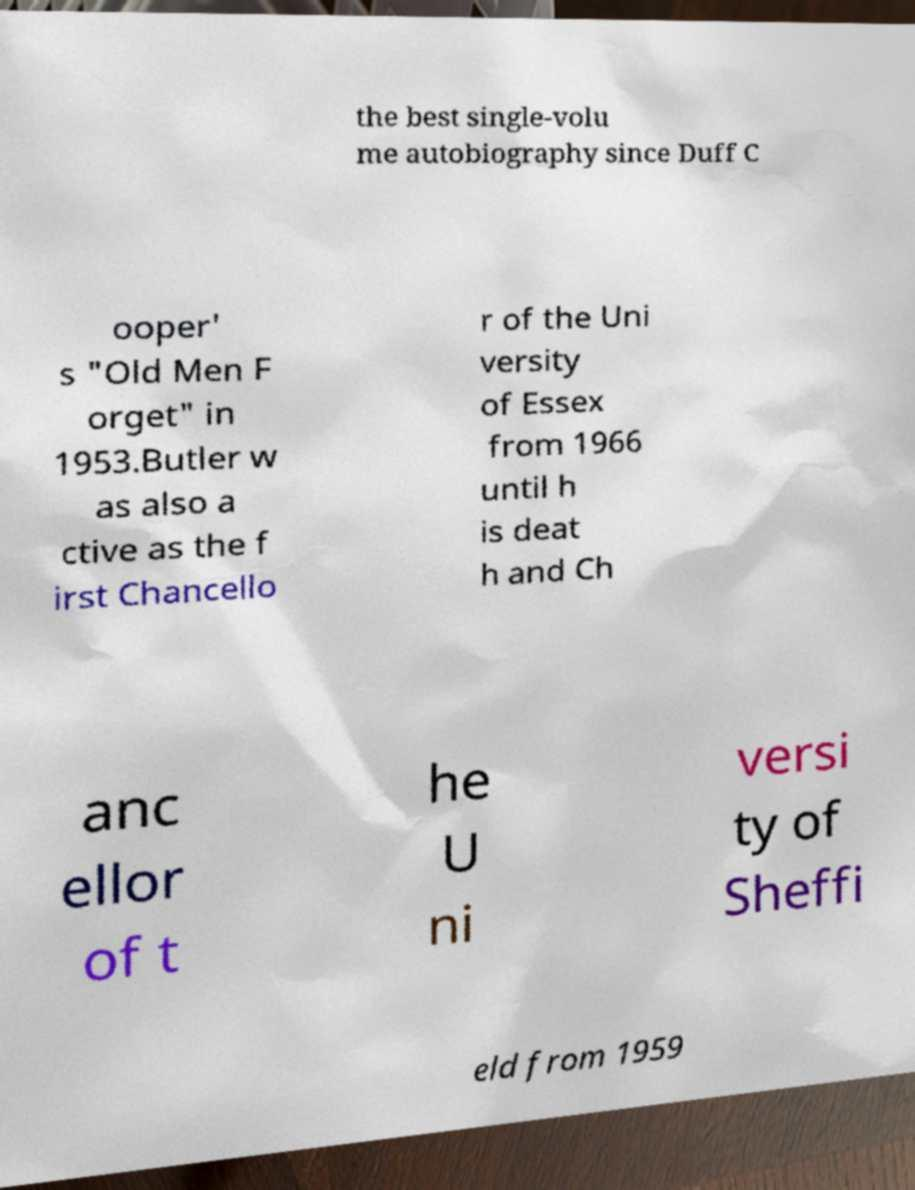Please read and relay the text visible in this image. What does it say? the best single-volu me autobiography since Duff C ooper' s "Old Men F orget" in 1953.Butler w as also a ctive as the f irst Chancello r of the Uni versity of Essex from 1966 until h is deat h and Ch anc ellor of t he U ni versi ty of Sheffi eld from 1959 